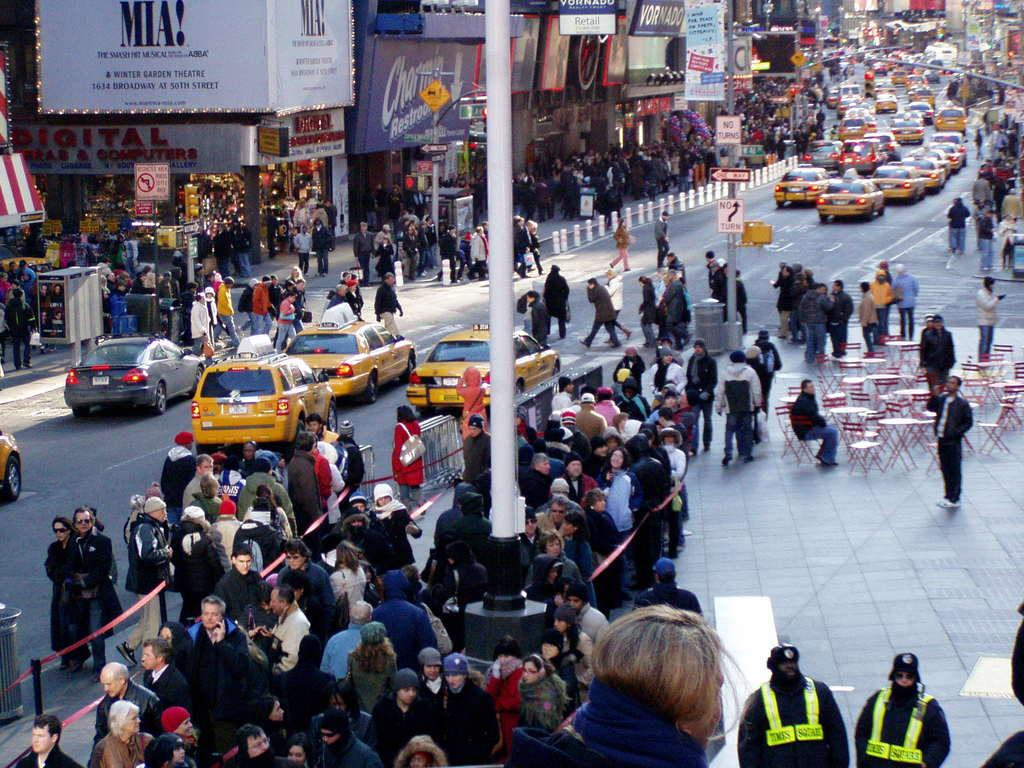<image>
Present a compact description of the photo's key features. a Mia advertisement that is outside in a busy city 